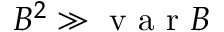Convert formula to latex. <formula><loc_0><loc_0><loc_500><loc_500>B ^ { 2 } \gg v a r B</formula> 